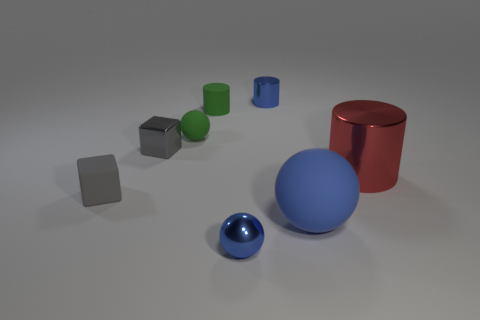There is a tiny blue cylinder; how many blue metallic things are to the left of it?
Your response must be concise. 1. Do the metallic cylinder behind the green sphere and the large blue sphere have the same size?
Your response must be concise. No. What is the color of the other rubber object that is the same shape as the large red thing?
Provide a short and direct response. Green. The tiny blue metal thing that is behind the small green matte cylinder has what shape?
Provide a short and direct response. Cylinder. What number of other small rubber objects are the same shape as the gray rubber thing?
Your answer should be very brief. 0. There is a small block in front of the metal cube; does it have the same color as the shiny thing to the left of the small green cylinder?
Offer a terse response. Yes. How many things are tiny gray blocks or small blue metallic things?
Offer a terse response. 4. What number of tiny objects have the same material as the large red cylinder?
Ensure brevity in your answer.  3. Is the number of small rubber balls less than the number of purple blocks?
Your answer should be compact. No. Does the tiny sphere on the left side of the tiny shiny ball have the same material as the large blue sphere?
Make the answer very short. Yes. 